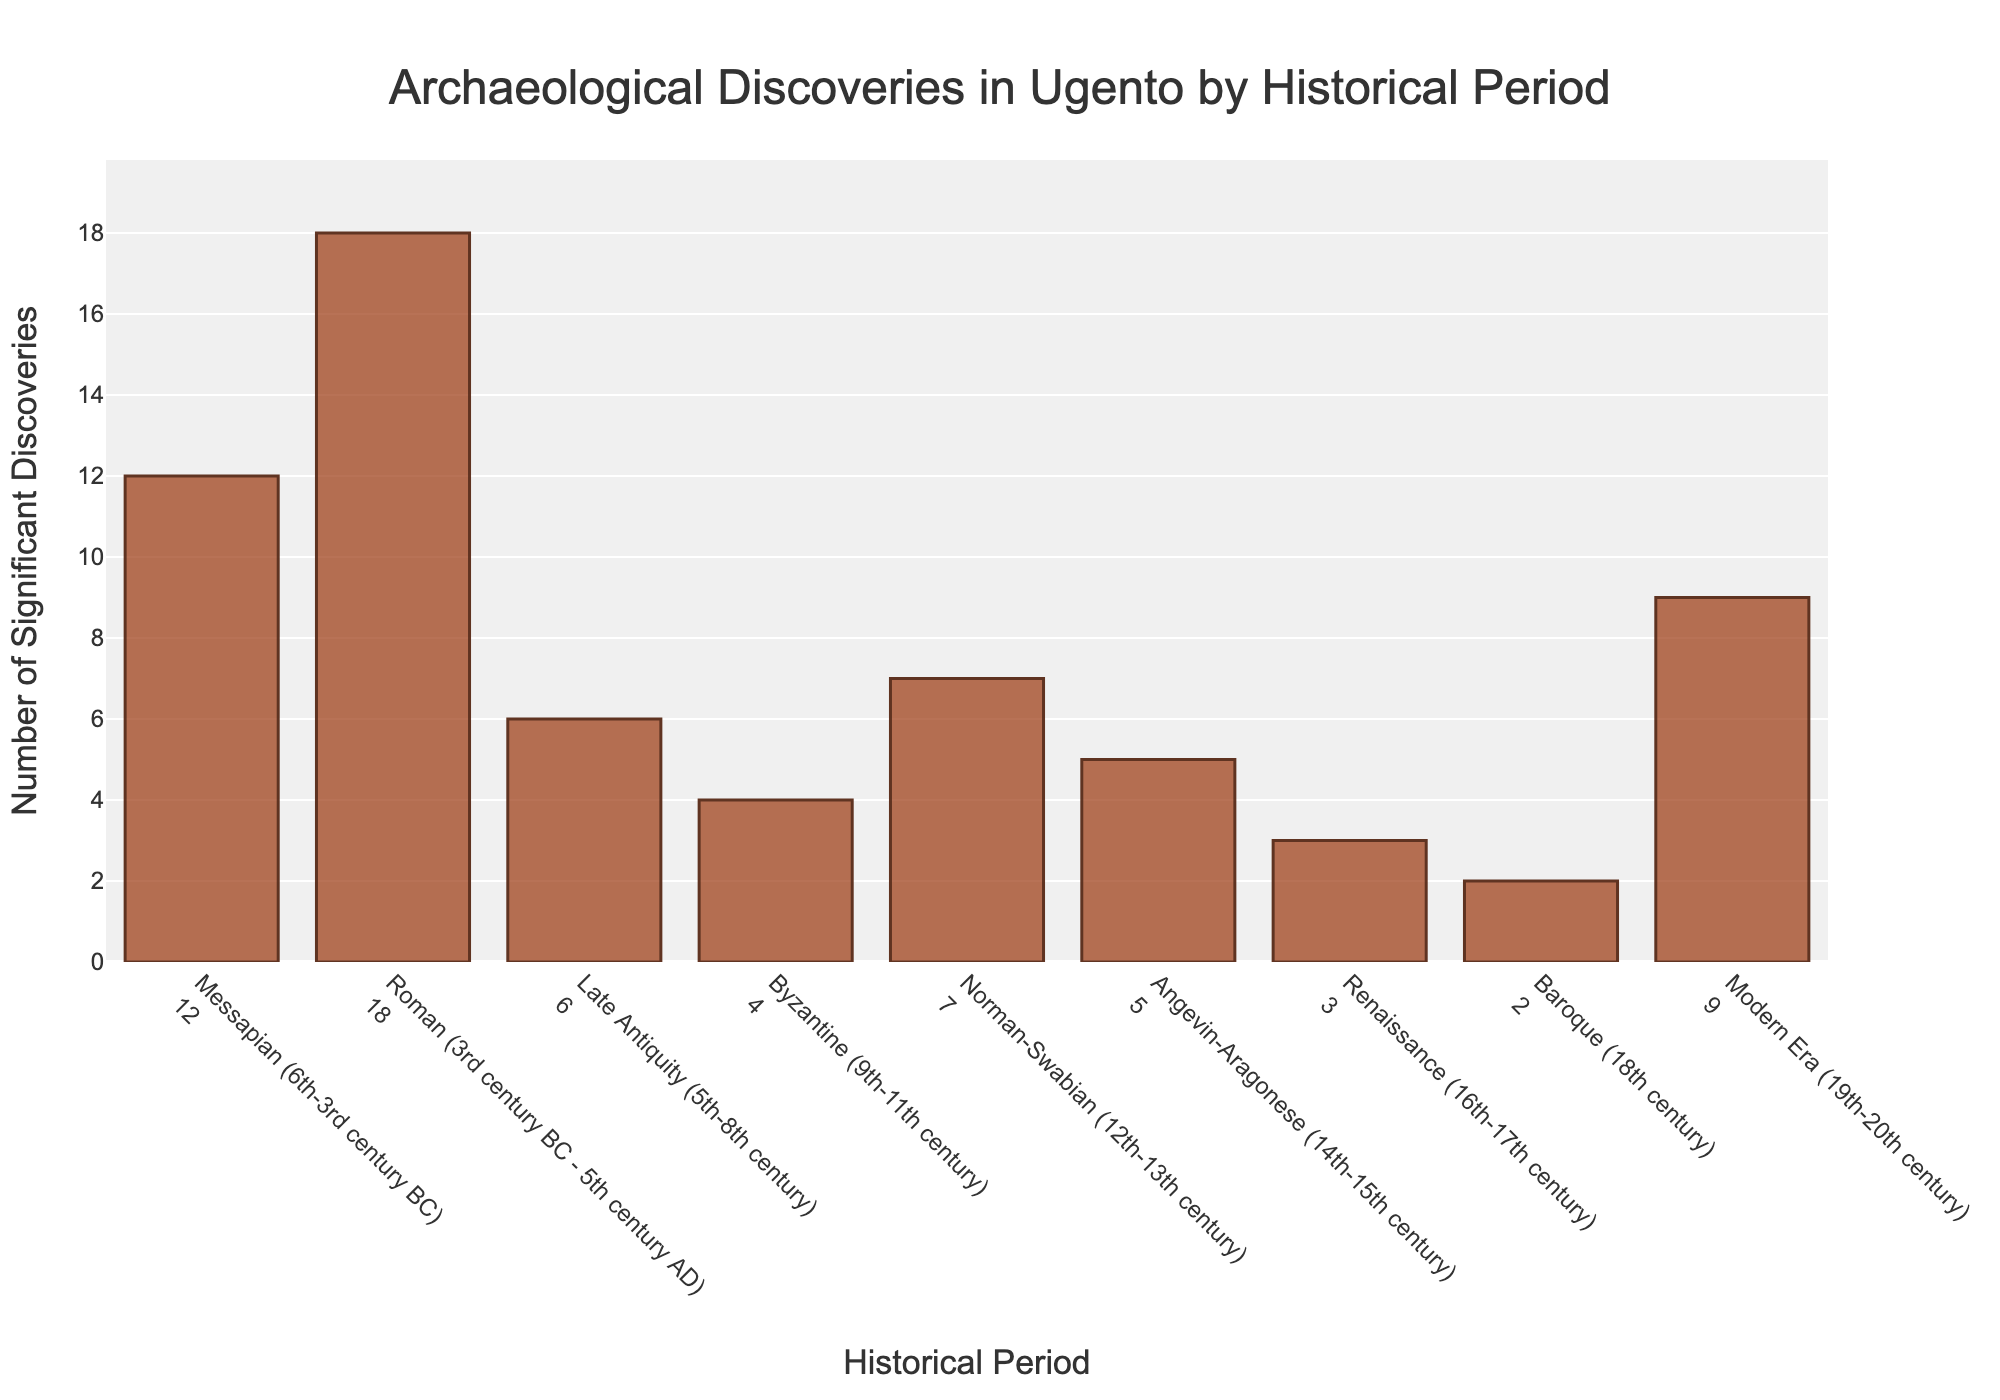Which historical period had the highest number of significant discoveries? Look at all bars and find the tallest one. The Roman period has the tallest bar.
Answer: Roman How many significant discoveries were made during the Medieval periods combined (Late Antiquity, Byzantine, Norman-Swabian, Angevin-Aragonese)? Add the values of the four periods. Late Antiquity (6) + Byzantine (4) + Norman-Swabian (7) + Angevin-Aragonese (5) = 22
Answer: 22 How many more significant discoveries were there in the Roman period compared to the Renaissance period? Subtract the number of Renaissance discoveries from the Roman discoveries. Roman (18) - Renaissance (3) = 15
Answer: 15 Which period had the least number of significant discoveries, and how many were there? Look for the shortest bar in the chart. The Baroque period has the shortest bar with a value of 2.
Answer: Baroque, 2 What is the total number of significant discoveries from the Messapian and Modern Era periods? Add the number of discoveries from both periods. Messapian (12) + Modern Era (9) = 21
Answer: 21 Which has more significant discoveries: the Byzantine period or the Angevin-Aragonese period? Compare the values of both periods. Byzantine (4) vs. Angevin-Aragonese (5). The Angevin-Aragonese period has more.
Answer: Angevin-Aragonese What is the average number of significant discoveries across all historical periods? Sum the total discoveries and divide by the number of periods. (12 + 18 + 6 + 4 + 7 + 5 + 3 + 2 + 9) / 9 = 66 / 9 ≈ 7.33
Answer: Approximately 7.33 How many periods have fewer than 5 significant discoveries? Count the bars with values less than 5: Byzantine (4), Renaissance (3), Baroque (2).
Answer: 3 If you combined the discoveries from the Late Antiquity and Baroque periods, would their total be greater than the discoveries in the Norman-Swabian period? Add the values of Late Antiquity and Baroque and compare with Norman-Swabian. Late Antiquity (6) + Baroque (2) = 8, which is greater than Norman-Swabian (7).
Answer: Yes Which historical period saw an increase in significant discoveries after the Byzantine period? Look at the period immediately following the Byzantine period and compare. Norman-Swabian (7) follows Byzantine (4) and has more discoveries.
Answer: Norman-Swabian 